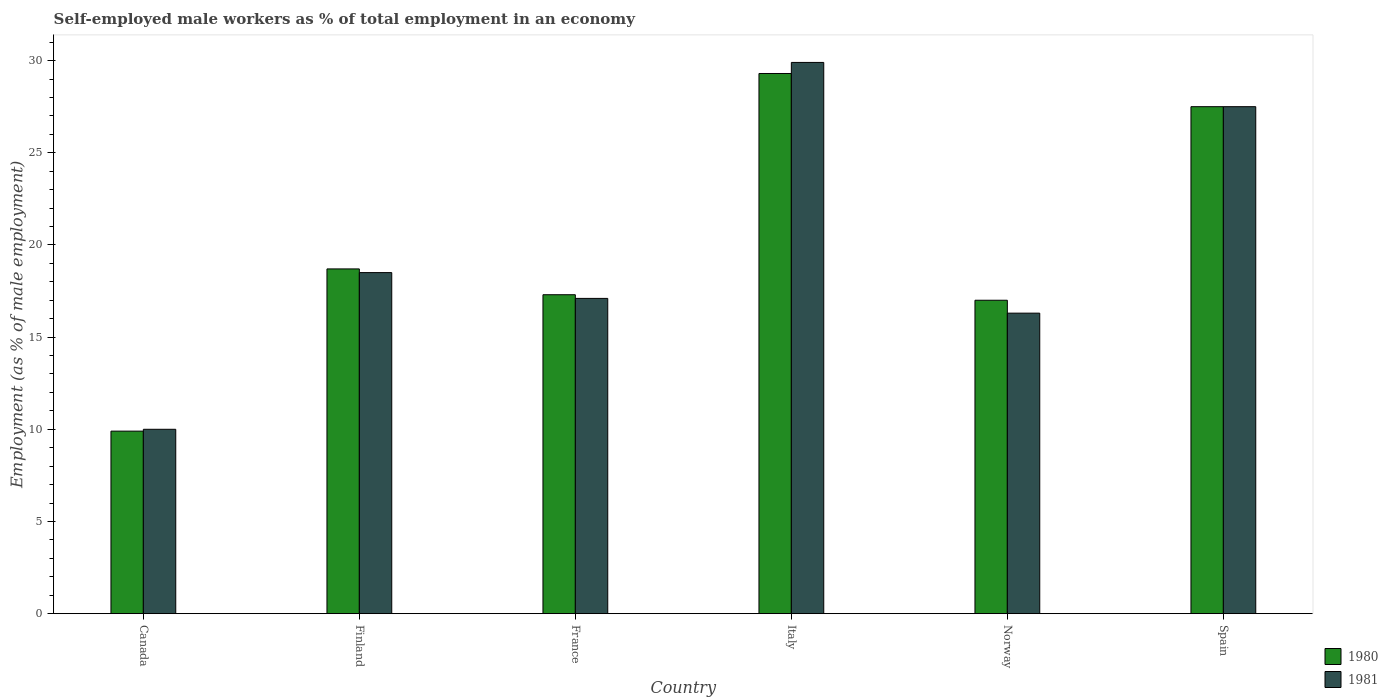How many different coloured bars are there?
Make the answer very short. 2. Are the number of bars per tick equal to the number of legend labels?
Keep it short and to the point. Yes. How many bars are there on the 3rd tick from the left?
Ensure brevity in your answer.  2. In how many cases, is the number of bars for a given country not equal to the number of legend labels?
Give a very brief answer. 0. What is the percentage of self-employed male workers in 1980 in Finland?
Your answer should be compact. 18.7. Across all countries, what is the maximum percentage of self-employed male workers in 1981?
Keep it short and to the point. 29.9. In which country was the percentage of self-employed male workers in 1981 maximum?
Ensure brevity in your answer.  Italy. In which country was the percentage of self-employed male workers in 1981 minimum?
Make the answer very short. Canada. What is the total percentage of self-employed male workers in 1981 in the graph?
Provide a succinct answer. 119.3. What is the difference between the percentage of self-employed male workers in 1981 in Norway and that in Spain?
Provide a short and direct response. -11.2. What is the difference between the percentage of self-employed male workers in 1981 in Finland and the percentage of self-employed male workers in 1980 in Canada?
Offer a terse response. 8.6. What is the average percentage of self-employed male workers in 1981 per country?
Keep it short and to the point. 19.88. What is the difference between the percentage of self-employed male workers of/in 1981 and percentage of self-employed male workers of/in 1980 in Norway?
Offer a very short reply. -0.7. What is the ratio of the percentage of self-employed male workers in 1980 in France to that in Italy?
Make the answer very short. 0.59. Is the percentage of self-employed male workers in 1981 in Finland less than that in Spain?
Provide a succinct answer. Yes. Is the difference between the percentage of self-employed male workers in 1981 in France and Italy greater than the difference between the percentage of self-employed male workers in 1980 in France and Italy?
Your answer should be very brief. No. What is the difference between the highest and the second highest percentage of self-employed male workers in 1981?
Your answer should be very brief. -9. What is the difference between the highest and the lowest percentage of self-employed male workers in 1981?
Offer a very short reply. 19.9. In how many countries, is the percentage of self-employed male workers in 1981 greater than the average percentage of self-employed male workers in 1981 taken over all countries?
Give a very brief answer. 2. What does the 1st bar from the right in Spain represents?
Give a very brief answer. 1981. Are all the bars in the graph horizontal?
Offer a terse response. No. What is the difference between two consecutive major ticks on the Y-axis?
Offer a very short reply. 5. Are the values on the major ticks of Y-axis written in scientific E-notation?
Your answer should be compact. No. Does the graph contain any zero values?
Give a very brief answer. No. Does the graph contain grids?
Keep it short and to the point. No. Where does the legend appear in the graph?
Make the answer very short. Bottom right. How many legend labels are there?
Your answer should be very brief. 2. How are the legend labels stacked?
Provide a succinct answer. Vertical. What is the title of the graph?
Ensure brevity in your answer.  Self-employed male workers as % of total employment in an economy. What is the label or title of the X-axis?
Your answer should be compact. Country. What is the label or title of the Y-axis?
Offer a very short reply. Employment (as % of male employment). What is the Employment (as % of male employment) in 1980 in Canada?
Make the answer very short. 9.9. What is the Employment (as % of male employment) in 1980 in Finland?
Make the answer very short. 18.7. What is the Employment (as % of male employment) of 1981 in Finland?
Keep it short and to the point. 18.5. What is the Employment (as % of male employment) of 1980 in France?
Provide a short and direct response. 17.3. What is the Employment (as % of male employment) of 1981 in France?
Ensure brevity in your answer.  17.1. What is the Employment (as % of male employment) in 1980 in Italy?
Give a very brief answer. 29.3. What is the Employment (as % of male employment) of 1981 in Italy?
Give a very brief answer. 29.9. What is the Employment (as % of male employment) of 1981 in Norway?
Make the answer very short. 16.3. What is the Employment (as % of male employment) of 1981 in Spain?
Keep it short and to the point. 27.5. Across all countries, what is the maximum Employment (as % of male employment) of 1980?
Ensure brevity in your answer.  29.3. Across all countries, what is the maximum Employment (as % of male employment) of 1981?
Provide a succinct answer. 29.9. Across all countries, what is the minimum Employment (as % of male employment) in 1980?
Your response must be concise. 9.9. What is the total Employment (as % of male employment) in 1980 in the graph?
Give a very brief answer. 119.7. What is the total Employment (as % of male employment) of 1981 in the graph?
Your response must be concise. 119.3. What is the difference between the Employment (as % of male employment) of 1981 in Canada and that in Finland?
Ensure brevity in your answer.  -8.5. What is the difference between the Employment (as % of male employment) in 1980 in Canada and that in France?
Make the answer very short. -7.4. What is the difference between the Employment (as % of male employment) of 1981 in Canada and that in France?
Your answer should be very brief. -7.1. What is the difference between the Employment (as % of male employment) in 1980 in Canada and that in Italy?
Your answer should be very brief. -19.4. What is the difference between the Employment (as % of male employment) of 1981 in Canada and that in Italy?
Your response must be concise. -19.9. What is the difference between the Employment (as % of male employment) of 1981 in Canada and that in Norway?
Your response must be concise. -6.3. What is the difference between the Employment (as % of male employment) in 1980 in Canada and that in Spain?
Provide a succinct answer. -17.6. What is the difference between the Employment (as % of male employment) in 1981 in Canada and that in Spain?
Your answer should be compact. -17.5. What is the difference between the Employment (as % of male employment) in 1980 in Finland and that in France?
Keep it short and to the point. 1.4. What is the difference between the Employment (as % of male employment) in 1980 in Finland and that in Norway?
Your response must be concise. 1.7. What is the difference between the Employment (as % of male employment) of 1981 in Finland and that in Spain?
Ensure brevity in your answer.  -9. What is the difference between the Employment (as % of male employment) in 1981 in France and that in Italy?
Offer a terse response. -12.8. What is the difference between the Employment (as % of male employment) in 1980 in France and that in Norway?
Make the answer very short. 0.3. What is the difference between the Employment (as % of male employment) in 1981 in France and that in Norway?
Ensure brevity in your answer.  0.8. What is the difference between the Employment (as % of male employment) in 1980 in Italy and that in Spain?
Your answer should be very brief. 1.8. What is the difference between the Employment (as % of male employment) of 1981 in Italy and that in Spain?
Your response must be concise. 2.4. What is the difference between the Employment (as % of male employment) in 1980 in Canada and the Employment (as % of male employment) in 1981 in Finland?
Offer a very short reply. -8.6. What is the difference between the Employment (as % of male employment) of 1980 in Canada and the Employment (as % of male employment) of 1981 in Spain?
Your response must be concise. -17.6. What is the difference between the Employment (as % of male employment) in 1980 in Finland and the Employment (as % of male employment) in 1981 in France?
Offer a very short reply. 1.6. What is the difference between the Employment (as % of male employment) in 1980 in France and the Employment (as % of male employment) in 1981 in Norway?
Your answer should be very brief. 1. What is the difference between the Employment (as % of male employment) of 1980 in France and the Employment (as % of male employment) of 1981 in Spain?
Your response must be concise. -10.2. What is the difference between the Employment (as % of male employment) in 1980 in Italy and the Employment (as % of male employment) in 1981 in Spain?
Give a very brief answer. 1.8. What is the average Employment (as % of male employment) of 1980 per country?
Offer a very short reply. 19.95. What is the average Employment (as % of male employment) in 1981 per country?
Your answer should be compact. 19.88. What is the difference between the Employment (as % of male employment) in 1980 and Employment (as % of male employment) in 1981 in Canada?
Your answer should be compact. -0.1. What is the difference between the Employment (as % of male employment) of 1980 and Employment (as % of male employment) of 1981 in Italy?
Give a very brief answer. -0.6. What is the difference between the Employment (as % of male employment) of 1980 and Employment (as % of male employment) of 1981 in Norway?
Provide a short and direct response. 0.7. What is the ratio of the Employment (as % of male employment) of 1980 in Canada to that in Finland?
Your answer should be very brief. 0.53. What is the ratio of the Employment (as % of male employment) of 1981 in Canada to that in Finland?
Your answer should be very brief. 0.54. What is the ratio of the Employment (as % of male employment) in 1980 in Canada to that in France?
Keep it short and to the point. 0.57. What is the ratio of the Employment (as % of male employment) in 1981 in Canada to that in France?
Ensure brevity in your answer.  0.58. What is the ratio of the Employment (as % of male employment) of 1980 in Canada to that in Italy?
Your response must be concise. 0.34. What is the ratio of the Employment (as % of male employment) in 1981 in Canada to that in Italy?
Keep it short and to the point. 0.33. What is the ratio of the Employment (as % of male employment) of 1980 in Canada to that in Norway?
Your response must be concise. 0.58. What is the ratio of the Employment (as % of male employment) of 1981 in Canada to that in Norway?
Your answer should be very brief. 0.61. What is the ratio of the Employment (as % of male employment) of 1980 in Canada to that in Spain?
Provide a short and direct response. 0.36. What is the ratio of the Employment (as % of male employment) of 1981 in Canada to that in Spain?
Give a very brief answer. 0.36. What is the ratio of the Employment (as % of male employment) of 1980 in Finland to that in France?
Offer a very short reply. 1.08. What is the ratio of the Employment (as % of male employment) in 1981 in Finland to that in France?
Your answer should be very brief. 1.08. What is the ratio of the Employment (as % of male employment) of 1980 in Finland to that in Italy?
Give a very brief answer. 0.64. What is the ratio of the Employment (as % of male employment) of 1981 in Finland to that in Italy?
Provide a short and direct response. 0.62. What is the ratio of the Employment (as % of male employment) in 1980 in Finland to that in Norway?
Your answer should be very brief. 1.1. What is the ratio of the Employment (as % of male employment) in 1981 in Finland to that in Norway?
Your answer should be very brief. 1.14. What is the ratio of the Employment (as % of male employment) of 1980 in Finland to that in Spain?
Offer a very short reply. 0.68. What is the ratio of the Employment (as % of male employment) in 1981 in Finland to that in Spain?
Your answer should be very brief. 0.67. What is the ratio of the Employment (as % of male employment) in 1980 in France to that in Italy?
Your answer should be very brief. 0.59. What is the ratio of the Employment (as % of male employment) in 1981 in France to that in Italy?
Keep it short and to the point. 0.57. What is the ratio of the Employment (as % of male employment) of 1980 in France to that in Norway?
Provide a short and direct response. 1.02. What is the ratio of the Employment (as % of male employment) in 1981 in France to that in Norway?
Your answer should be very brief. 1.05. What is the ratio of the Employment (as % of male employment) in 1980 in France to that in Spain?
Provide a succinct answer. 0.63. What is the ratio of the Employment (as % of male employment) in 1981 in France to that in Spain?
Ensure brevity in your answer.  0.62. What is the ratio of the Employment (as % of male employment) of 1980 in Italy to that in Norway?
Your answer should be very brief. 1.72. What is the ratio of the Employment (as % of male employment) of 1981 in Italy to that in Norway?
Make the answer very short. 1.83. What is the ratio of the Employment (as % of male employment) of 1980 in Italy to that in Spain?
Ensure brevity in your answer.  1.07. What is the ratio of the Employment (as % of male employment) in 1981 in Italy to that in Spain?
Your response must be concise. 1.09. What is the ratio of the Employment (as % of male employment) of 1980 in Norway to that in Spain?
Give a very brief answer. 0.62. What is the ratio of the Employment (as % of male employment) in 1981 in Norway to that in Spain?
Your answer should be compact. 0.59. What is the difference between the highest and the second highest Employment (as % of male employment) of 1980?
Your response must be concise. 1.8. What is the difference between the highest and the second highest Employment (as % of male employment) in 1981?
Make the answer very short. 2.4. What is the difference between the highest and the lowest Employment (as % of male employment) in 1981?
Give a very brief answer. 19.9. 